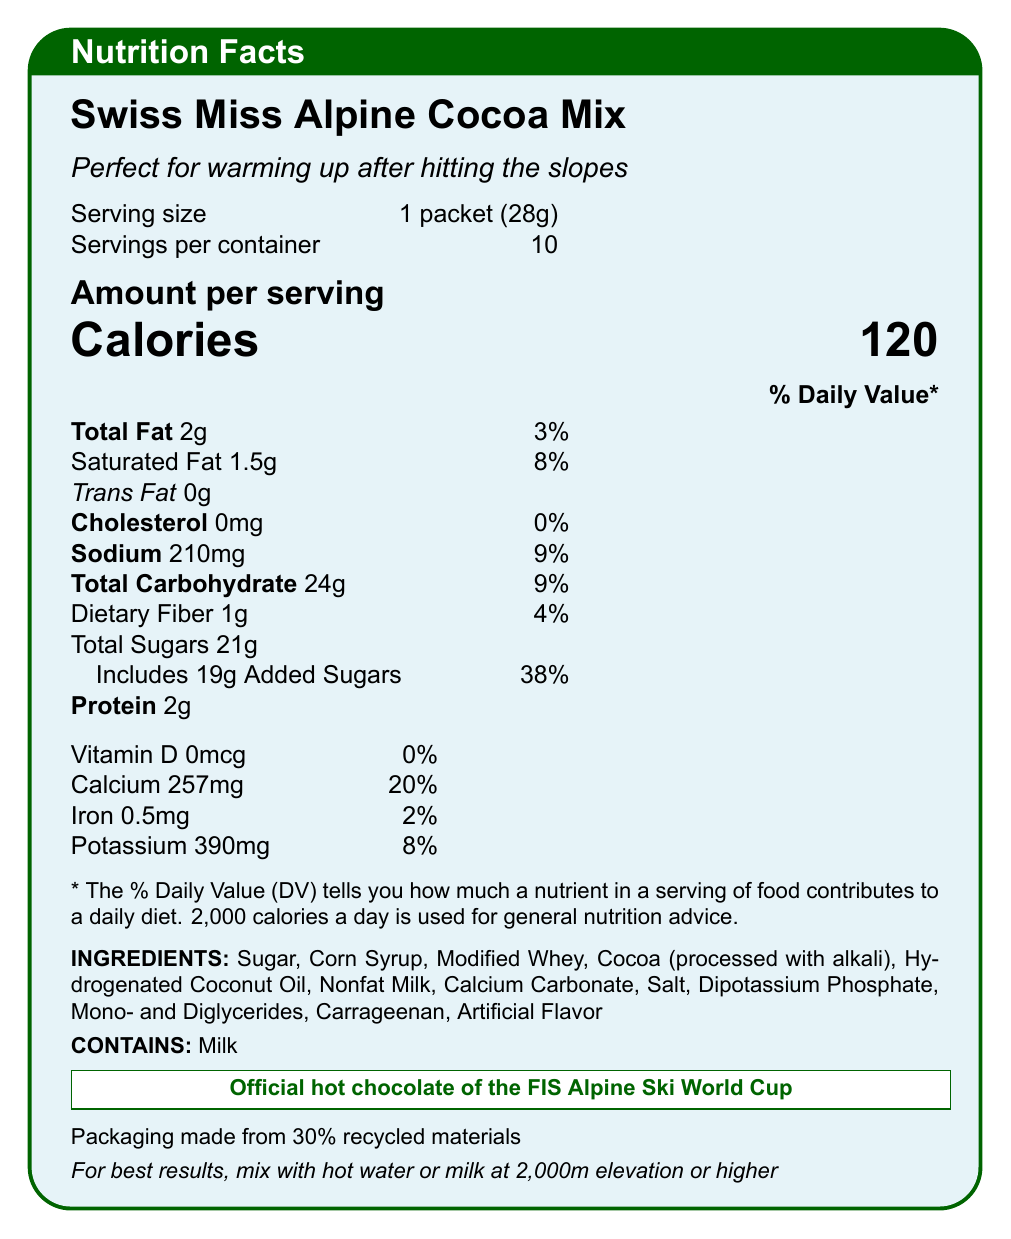what is the serving size of the Swiss Miss Alpine Cocoa Mix? The document states the serving size at the top of the nutrition facts section.
Answer: 1 packet (28g) how many calories are in one serving? The document lists the calories per serving prominently in the "Amount per serving" section.
Answer: 120 calories how much total fat is in one serving? The "Total Fat" content in the "Amount per serving" section lists this amount.
Answer: 2g how much sugar does one serving contain? The "Total Sugars" listed in the "Amount per serving" section shows this value.
Answer: 21g how many servings are in the container? The document specifies "Servings per container" as 10 at the beginning of the nutrition facts section.
Answer: 10 what percentage of daily value of calcium does one serving provide? In the document, calcium is listed with its daily value percentage, which is 20%.
Answer: 20% does this product contain any cholesterol? The document specifies that there is 0mg of cholesterol, which means it contains no cholesterol.
Answer: No which international championship endorses this hot chocolate? The document states "Official hot chocolate of the FIS Alpine Ski World Cup" near the end.
Answer: FIS Alpine Ski World Cup how much sodium is in one serving? The "Amount per serving" section lists the sodium content as 210mg.
Answer: 210mg what is one ingredient that contributes to the protein content? The ingredients list includes "Modified Whey," which is likely a protein source.
Answer: Modified Whey which of the following vitamins or minerals is not notably present in this product? A. Vitamin D B. Calcium C. Iron D. Potassium The document notes Vitamin D as 0mcg (0%), indicating it is not notably present.
Answer: A. Vitamin D which of the following is present in the highest daily value percentage? A. Total Fat B. Added Sugars C. Iron D. Dietary Fiber The added sugars provide 38% of the daily value, which is the highest percentage listed.
Answer: B. Added Sugars is this product produced with ingredients derived from milk? The allergen information specifies "Contains: Milk," indicating milk-derived ingredients.
Answer: Yes can you determine the exact elevation recommended for preparation? The document recommends mixing "at 2,000m elevation or higher."
Answer: Yes what are the main insights of the document? The document includes detailed nutrition information per serving size, ingredients, allergen notes, and endorsements, highlighting the product's connection to alpine skiing and environmental sustainability.
Answer: The document provides the nutrition facts, ingredients list, and allergen information for Swiss Miss Alpine Cocoa Mix, emphasizing its suitability for consumption after skiing and detailing its endorsement by the FIS Alpine Ski World Cup. what are the environmental sustainability practices mentioned for this product? The document notes that the packaging is made from 30% recycled materials, indicating an environmental sustainability practice.
Answer: Packaging made from 30% recycled materials what is the purpose of the "daily value" percentages listed? The document explains that daily value percentages show the contribution of each nutrient to a daily diet, based on a 2,000 calorie per day guideline.
Answer: To indicate how much a nutrient in a serving contributes to a daily diet when the total carbohydrate content is 24g, how much of it comes from added sugars alone? The document specifies that out of 24g of total carbohydrates, 19g are added sugars.
Answer: 19g what is the stance of Swiss Miss on artificial flavoring? The ingredients list includes "Artificial Flavor," indicating the use of artificial flavoring in the product.
Answer: Uses artificial flavor can you find information on whether the product is gluten-free? The document does not provide any information about whether the product is gluten-free.
Answer: Not enough information 